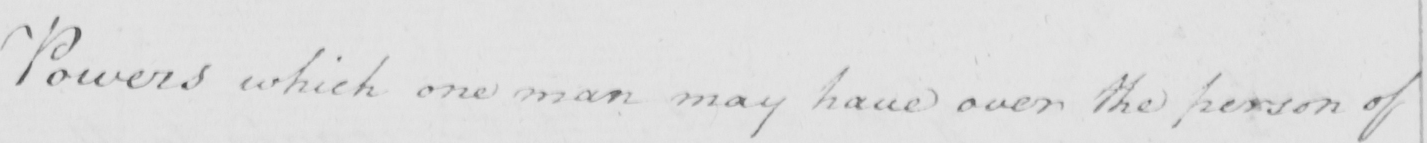What does this handwritten line say? Powers which one man may have over the person of 